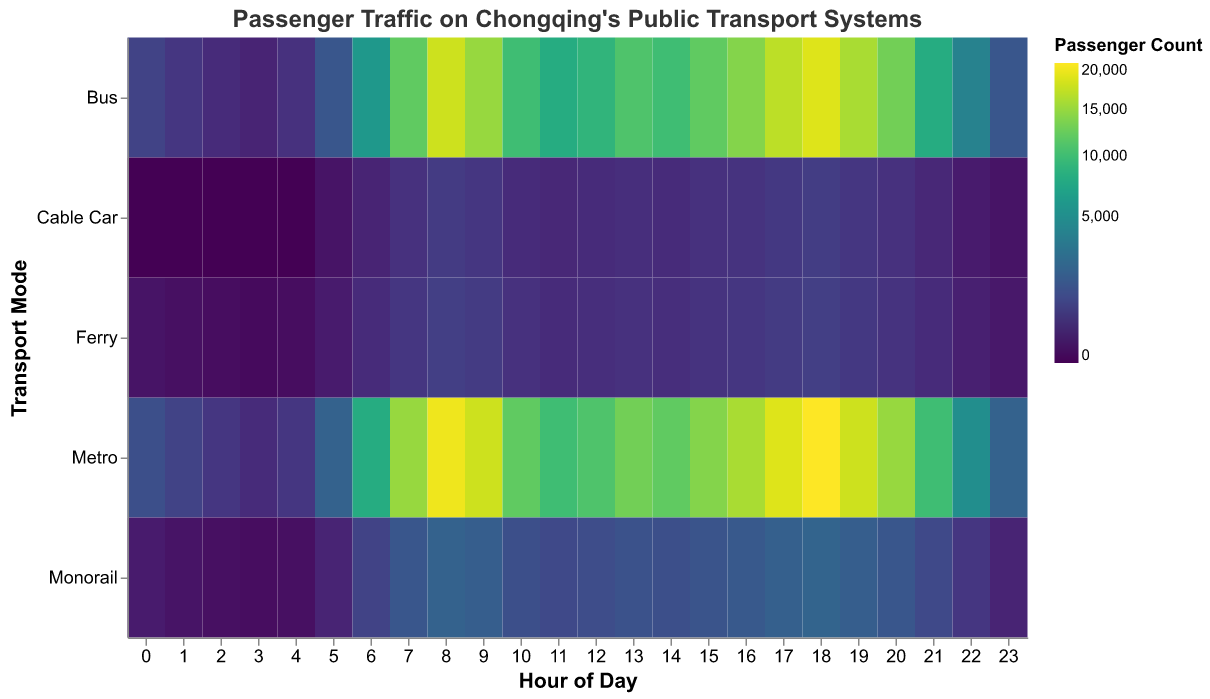What's the title of the figure? The title of the figure is displayed at the top and reads "Passenger Traffic on Chongqing's Public Transport Systems".
Answer: Passenger Traffic on Chongqing's Public Transport Systems At what hour is the metro passenger count the highest? The carpet plot uses color intensity to indicate the number of passengers; the brightest color for the metro is at 18:00, which indicates the highest passenger count.
Answer: 18:00 How many passengers use the bus at 8:00? Find the cell corresponding to hour 8 and the bus row; the color indicates that 18,000 passengers use the bus at this hour.
Answer: 18,000 What is the total passenger count for the ferry at 7:00 and 20:00? The ferry passenger count at 7:00 and 20:00 are 500 and 450 respectively. Adding both values gives 500 + 450 = 950.
Answer: 950 Which transport mode shows zero passengers at several hours? Looking at the colors for each transport mode across hours, the cable car has several hours with no color, indicating zero passengers at those times.
Answer: Cable Car Compare passenger counts between the metro and the monorail at 9:00. Which has more passengers, and by how much? At 9:00, the metro has 18,000 passengers while the monorail has 1,800 passengers. The metro has more passengers by 18,000 - 1,800 = 16,200.
Answer: Metro by 16,200 During which hours does the bus passenger count exceed 15,000? Find cells with color intensity indicating above 15,000 for the bus row. These hours are 7:00, 8:00, 9:00, and 17:00, 18:00.
Answer: 7:00, 8:00, 9:00, 17:00, 18:00 What's the average number of passengers using the metro between 5:00 and 7:00? Add the passenger counts for the metro at 5:00 (2,000), 6:00 (8,000), and 7:00 (15,000), sum = 25,000. Divide by the number of hours (3) to get the average = 25,000 / 3 ≈ 8,333.
Answer: ~8,333 Which transport mode sees the highest variability in passenger counts throughout the day? The metro shows the highest variability with a wide range of passenger counts from as low as 300 to as high as 21,000 which is visually evident from different shades.
Answer: Metro 